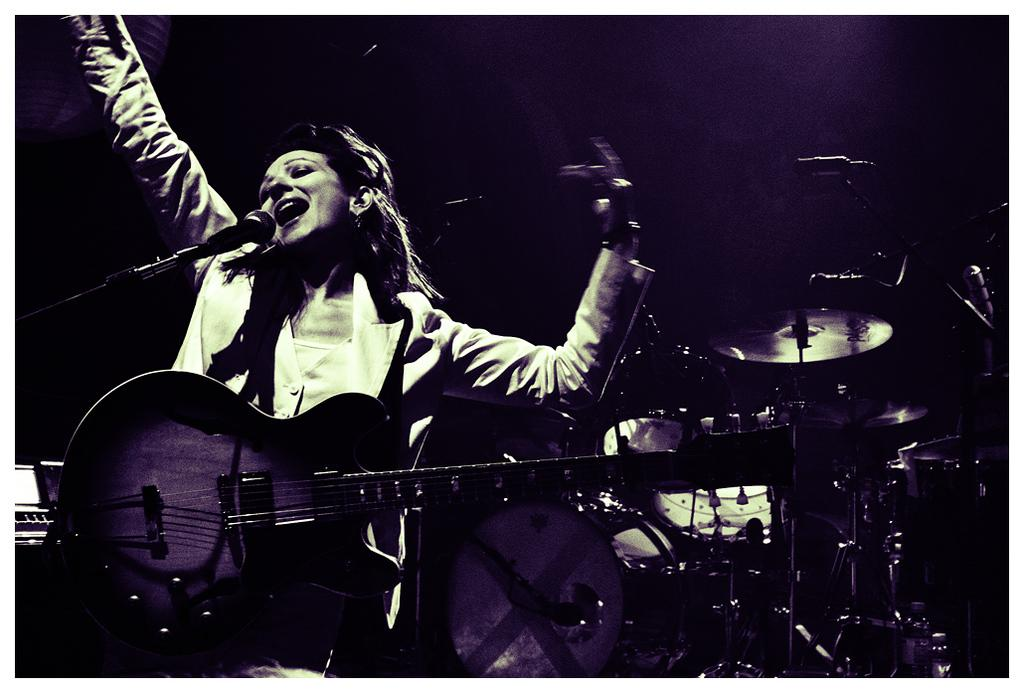What is the person holding in the image? The person is holding a guitar. What is the person doing with the guitar? The person is singing while holding the guitar. What other musical instrument can be seen in the image? There is a musical instrument visible behind the person. What is the person using to amplify their voice in the image? There is a microphone with a stand in the image. What type of weather can be seen in the image? There is no weather visible in the image, as it is focused on the person and their musical performance. 